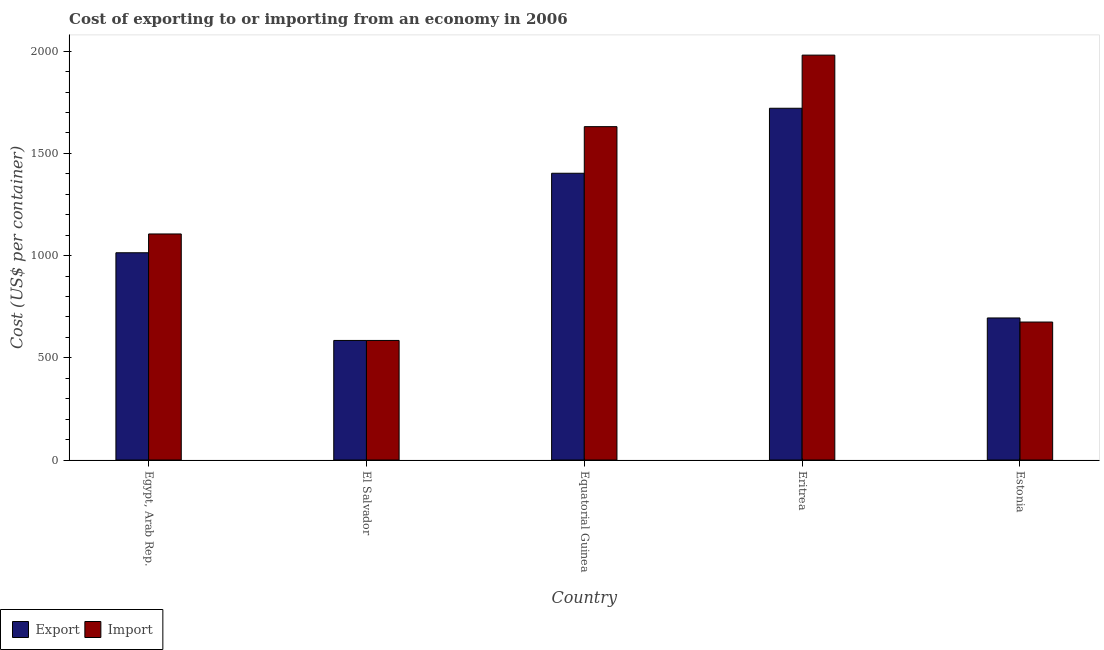How many different coloured bars are there?
Your answer should be compact. 2. How many groups of bars are there?
Provide a short and direct response. 5. Are the number of bars per tick equal to the number of legend labels?
Provide a succinct answer. Yes. What is the label of the 5th group of bars from the left?
Provide a short and direct response. Estonia. What is the export cost in Equatorial Guinea?
Your answer should be very brief. 1403. Across all countries, what is the maximum export cost?
Make the answer very short. 1721. Across all countries, what is the minimum import cost?
Keep it short and to the point. 585. In which country was the export cost maximum?
Offer a terse response. Eritrea. In which country was the import cost minimum?
Keep it short and to the point. El Salvador. What is the total export cost in the graph?
Provide a short and direct response. 5418. What is the difference between the import cost in El Salvador and that in Equatorial Guinea?
Offer a terse response. -1046. What is the difference between the import cost in Estonia and the export cost in Equatorial Guinea?
Make the answer very short. -728. What is the average export cost per country?
Keep it short and to the point. 1083.6. What is the difference between the import cost and export cost in Equatorial Guinea?
Offer a very short reply. 228. In how many countries, is the export cost greater than 1200 US$?
Your answer should be very brief. 2. What is the ratio of the import cost in El Salvador to that in Eritrea?
Provide a short and direct response. 0.3. What is the difference between the highest and the second highest import cost?
Keep it short and to the point. 350. What is the difference between the highest and the lowest export cost?
Offer a terse response. 1136. What does the 2nd bar from the left in El Salvador represents?
Give a very brief answer. Import. What does the 1st bar from the right in Estonia represents?
Provide a short and direct response. Import. How many bars are there?
Provide a short and direct response. 10. Does the graph contain grids?
Provide a short and direct response. No. Where does the legend appear in the graph?
Offer a very short reply. Bottom left. How many legend labels are there?
Keep it short and to the point. 2. How are the legend labels stacked?
Offer a terse response. Horizontal. What is the title of the graph?
Give a very brief answer. Cost of exporting to or importing from an economy in 2006. Does "Female population" appear as one of the legend labels in the graph?
Provide a short and direct response. No. What is the label or title of the Y-axis?
Make the answer very short. Cost (US$ per container). What is the Cost (US$ per container) of Export in Egypt, Arab Rep.?
Make the answer very short. 1014. What is the Cost (US$ per container) of Import in Egypt, Arab Rep.?
Your response must be concise. 1106. What is the Cost (US$ per container) in Export in El Salvador?
Provide a succinct answer. 585. What is the Cost (US$ per container) in Import in El Salvador?
Your answer should be compact. 585. What is the Cost (US$ per container) of Export in Equatorial Guinea?
Give a very brief answer. 1403. What is the Cost (US$ per container) of Import in Equatorial Guinea?
Provide a succinct answer. 1631. What is the Cost (US$ per container) in Export in Eritrea?
Give a very brief answer. 1721. What is the Cost (US$ per container) of Import in Eritrea?
Your answer should be compact. 1981. What is the Cost (US$ per container) of Export in Estonia?
Make the answer very short. 695. What is the Cost (US$ per container) of Import in Estonia?
Provide a short and direct response. 675. Across all countries, what is the maximum Cost (US$ per container) in Export?
Provide a succinct answer. 1721. Across all countries, what is the maximum Cost (US$ per container) of Import?
Give a very brief answer. 1981. Across all countries, what is the minimum Cost (US$ per container) in Export?
Keep it short and to the point. 585. Across all countries, what is the minimum Cost (US$ per container) in Import?
Give a very brief answer. 585. What is the total Cost (US$ per container) of Export in the graph?
Offer a very short reply. 5418. What is the total Cost (US$ per container) in Import in the graph?
Your answer should be compact. 5978. What is the difference between the Cost (US$ per container) in Export in Egypt, Arab Rep. and that in El Salvador?
Your response must be concise. 429. What is the difference between the Cost (US$ per container) in Import in Egypt, Arab Rep. and that in El Salvador?
Your answer should be very brief. 521. What is the difference between the Cost (US$ per container) in Export in Egypt, Arab Rep. and that in Equatorial Guinea?
Give a very brief answer. -389. What is the difference between the Cost (US$ per container) in Import in Egypt, Arab Rep. and that in Equatorial Guinea?
Your answer should be very brief. -525. What is the difference between the Cost (US$ per container) in Export in Egypt, Arab Rep. and that in Eritrea?
Keep it short and to the point. -707. What is the difference between the Cost (US$ per container) in Import in Egypt, Arab Rep. and that in Eritrea?
Provide a short and direct response. -875. What is the difference between the Cost (US$ per container) of Export in Egypt, Arab Rep. and that in Estonia?
Ensure brevity in your answer.  319. What is the difference between the Cost (US$ per container) in Import in Egypt, Arab Rep. and that in Estonia?
Keep it short and to the point. 431. What is the difference between the Cost (US$ per container) of Export in El Salvador and that in Equatorial Guinea?
Provide a succinct answer. -818. What is the difference between the Cost (US$ per container) in Import in El Salvador and that in Equatorial Guinea?
Give a very brief answer. -1046. What is the difference between the Cost (US$ per container) of Export in El Salvador and that in Eritrea?
Give a very brief answer. -1136. What is the difference between the Cost (US$ per container) of Import in El Salvador and that in Eritrea?
Your response must be concise. -1396. What is the difference between the Cost (US$ per container) in Export in El Salvador and that in Estonia?
Give a very brief answer. -110. What is the difference between the Cost (US$ per container) of Import in El Salvador and that in Estonia?
Your response must be concise. -90. What is the difference between the Cost (US$ per container) in Export in Equatorial Guinea and that in Eritrea?
Provide a short and direct response. -318. What is the difference between the Cost (US$ per container) of Import in Equatorial Guinea and that in Eritrea?
Offer a very short reply. -350. What is the difference between the Cost (US$ per container) of Export in Equatorial Guinea and that in Estonia?
Offer a very short reply. 708. What is the difference between the Cost (US$ per container) of Import in Equatorial Guinea and that in Estonia?
Offer a very short reply. 956. What is the difference between the Cost (US$ per container) in Export in Eritrea and that in Estonia?
Your answer should be compact. 1026. What is the difference between the Cost (US$ per container) of Import in Eritrea and that in Estonia?
Your answer should be very brief. 1306. What is the difference between the Cost (US$ per container) in Export in Egypt, Arab Rep. and the Cost (US$ per container) in Import in El Salvador?
Make the answer very short. 429. What is the difference between the Cost (US$ per container) in Export in Egypt, Arab Rep. and the Cost (US$ per container) in Import in Equatorial Guinea?
Give a very brief answer. -617. What is the difference between the Cost (US$ per container) of Export in Egypt, Arab Rep. and the Cost (US$ per container) of Import in Eritrea?
Keep it short and to the point. -967. What is the difference between the Cost (US$ per container) of Export in Egypt, Arab Rep. and the Cost (US$ per container) of Import in Estonia?
Your answer should be compact. 339. What is the difference between the Cost (US$ per container) of Export in El Salvador and the Cost (US$ per container) of Import in Equatorial Guinea?
Offer a very short reply. -1046. What is the difference between the Cost (US$ per container) of Export in El Salvador and the Cost (US$ per container) of Import in Eritrea?
Your response must be concise. -1396. What is the difference between the Cost (US$ per container) of Export in El Salvador and the Cost (US$ per container) of Import in Estonia?
Ensure brevity in your answer.  -90. What is the difference between the Cost (US$ per container) of Export in Equatorial Guinea and the Cost (US$ per container) of Import in Eritrea?
Provide a succinct answer. -578. What is the difference between the Cost (US$ per container) of Export in Equatorial Guinea and the Cost (US$ per container) of Import in Estonia?
Make the answer very short. 728. What is the difference between the Cost (US$ per container) of Export in Eritrea and the Cost (US$ per container) of Import in Estonia?
Your answer should be compact. 1046. What is the average Cost (US$ per container) of Export per country?
Make the answer very short. 1083.6. What is the average Cost (US$ per container) of Import per country?
Provide a short and direct response. 1195.6. What is the difference between the Cost (US$ per container) in Export and Cost (US$ per container) in Import in Egypt, Arab Rep.?
Make the answer very short. -92. What is the difference between the Cost (US$ per container) of Export and Cost (US$ per container) of Import in El Salvador?
Offer a very short reply. 0. What is the difference between the Cost (US$ per container) of Export and Cost (US$ per container) of Import in Equatorial Guinea?
Provide a succinct answer. -228. What is the difference between the Cost (US$ per container) in Export and Cost (US$ per container) in Import in Eritrea?
Keep it short and to the point. -260. What is the ratio of the Cost (US$ per container) of Export in Egypt, Arab Rep. to that in El Salvador?
Your answer should be very brief. 1.73. What is the ratio of the Cost (US$ per container) in Import in Egypt, Arab Rep. to that in El Salvador?
Offer a very short reply. 1.89. What is the ratio of the Cost (US$ per container) of Export in Egypt, Arab Rep. to that in Equatorial Guinea?
Ensure brevity in your answer.  0.72. What is the ratio of the Cost (US$ per container) of Import in Egypt, Arab Rep. to that in Equatorial Guinea?
Ensure brevity in your answer.  0.68. What is the ratio of the Cost (US$ per container) in Export in Egypt, Arab Rep. to that in Eritrea?
Offer a very short reply. 0.59. What is the ratio of the Cost (US$ per container) in Import in Egypt, Arab Rep. to that in Eritrea?
Your response must be concise. 0.56. What is the ratio of the Cost (US$ per container) of Export in Egypt, Arab Rep. to that in Estonia?
Offer a terse response. 1.46. What is the ratio of the Cost (US$ per container) of Import in Egypt, Arab Rep. to that in Estonia?
Make the answer very short. 1.64. What is the ratio of the Cost (US$ per container) in Export in El Salvador to that in Equatorial Guinea?
Your response must be concise. 0.42. What is the ratio of the Cost (US$ per container) in Import in El Salvador to that in Equatorial Guinea?
Keep it short and to the point. 0.36. What is the ratio of the Cost (US$ per container) of Export in El Salvador to that in Eritrea?
Your response must be concise. 0.34. What is the ratio of the Cost (US$ per container) of Import in El Salvador to that in Eritrea?
Make the answer very short. 0.3. What is the ratio of the Cost (US$ per container) in Export in El Salvador to that in Estonia?
Keep it short and to the point. 0.84. What is the ratio of the Cost (US$ per container) of Import in El Salvador to that in Estonia?
Offer a terse response. 0.87. What is the ratio of the Cost (US$ per container) of Export in Equatorial Guinea to that in Eritrea?
Your response must be concise. 0.82. What is the ratio of the Cost (US$ per container) in Import in Equatorial Guinea to that in Eritrea?
Ensure brevity in your answer.  0.82. What is the ratio of the Cost (US$ per container) in Export in Equatorial Guinea to that in Estonia?
Provide a succinct answer. 2.02. What is the ratio of the Cost (US$ per container) of Import in Equatorial Guinea to that in Estonia?
Your response must be concise. 2.42. What is the ratio of the Cost (US$ per container) in Export in Eritrea to that in Estonia?
Offer a terse response. 2.48. What is the ratio of the Cost (US$ per container) in Import in Eritrea to that in Estonia?
Ensure brevity in your answer.  2.93. What is the difference between the highest and the second highest Cost (US$ per container) of Export?
Your answer should be very brief. 318. What is the difference between the highest and the second highest Cost (US$ per container) of Import?
Offer a terse response. 350. What is the difference between the highest and the lowest Cost (US$ per container) of Export?
Your response must be concise. 1136. What is the difference between the highest and the lowest Cost (US$ per container) of Import?
Make the answer very short. 1396. 